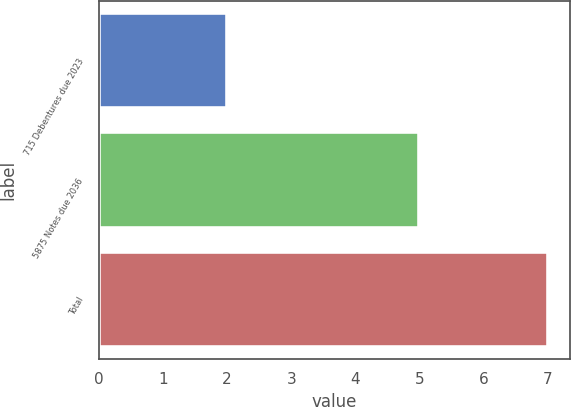<chart> <loc_0><loc_0><loc_500><loc_500><bar_chart><fcel>715 Debentures due 2023<fcel>5875 Notes due 2036<fcel>Total<nl><fcel>2<fcel>5<fcel>7<nl></chart> 